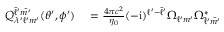Convert formula to latex. <formula><loc_0><loc_0><loc_500><loc_500>\begin{array} { r l } { Q _ { \lambda ^ { \prime } \ell ^ { \prime } m ^ { \prime } } ^ { \bar { \ell } ^ { \prime } \bar { m ^ { \prime } } } ( \theta ^ { \prime } , \phi ^ { \prime } ) } & = \frac { 4 \pi c ^ { 2 } } { \eta _ { 0 } } ( - i ) ^ { \ell ^ { \prime } - \bar { \ell } ^ { \prime } } \Omega _ { \ell ^ { \prime } m ^ { \prime } } \Omega _ { \bar { \ell } ^ { \prime } \bar { m ^ { \prime } } } ^ { * } } \end{array}</formula> 